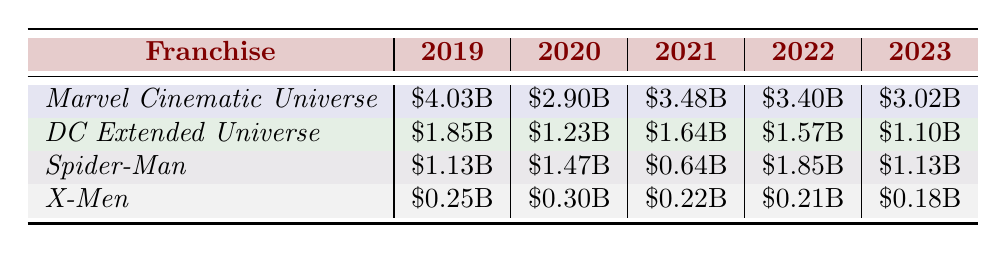What was the highest box office earning for the *Marvel Cinematic Universe* in the last five years? The highest box office earning for the *Marvel Cinematic Universe* occurred in 2019, which was \$4.03 billion.
Answer: \$4.03 billion Which superhero franchise had the lowest box office earnings in 2023? According to the table, the *X-Men* franchise had the lowest box office earnings in 2023, amounting to \$0.18 billion.
Answer: \$0.18 billion What is the total box office earnings of the *Spider-Man* franchise across all years listed? Summing the box office earnings for the *Spider-Man* franchise: \$1.13B + \$1.47B + \$0.64B + \$1.85B + \$1.13B gives \$5.22B.
Answer: \$5.22 billion Has the box office earning for the *DC Extended Universe* decreased every year from 2019 to 2023? Yes, the table shows that the earnings for the *DC Extended Universe* decreased from \$1.85 billion in 2019 to \$1.10 billion in 2023, indicating a continuous decrease.
Answer: Yes What was the average box office earning for the *X-Men* franchise over the last five years? The total box office earnings for *X-Men* is \$0.25B + \$0.30B + \$0.22B + \$0.21B + \$0.18B = \$1.16B. Dividing by 5 gives an average of \$0.232B.
Answer: \$0.232 billion Which franchise experienced the largest decrease in earnings from 2019 to 2020? Comparing the two years, the *Marvel Cinematic Universe* decreased from \$4.03B in 2019 to \$2.90B in 2020, which is a decrease of \$1.13 billion, the largest among all franchises.
Answer: *Marvel Cinematic Universe* Was there an increase in box office earnings for the *Spider-Man* franchise from 2021 to 2022? Yes, the *Spider-Man* franchise increased from \$0.64 billion in 2021 to \$1.85 billion in 2022, showing a significant increase.
Answer: Yes Calculate the total box office earnings for the *Marvel Cinematic Universe* from 2019 to 2023. Adding the earnings from each year: \$4.03B + \$2.90B + \$3.48B + \$3.40B + \$3.01B results in \$16.12B.
Answer: \$16.12 billion Which franchise had consistent earnings of over one billion dollars every year, except for one year? The *Spider-Man* franchise had earnings over one billion dollars in every year listed except for 2021, when it earned \$0.64 billion.
Answer: *Spider-Man* In which year did the *DC Extended Universe* earn more than \$1.5 billion? The *DC Extended Universe* earned more than \$1.5 billion only in 2019, totaling \$1.85 billion.
Answer: 2019 What was the difference in earnings between the *Marvel Cinematic Universe* and *DC Extended Universe* in 2022? The *Marvel Cinematic Universe* earned \$3.40 billion while the *DC Extended Universe* earned \$1.57 billion in 2022. The difference is \$3.40B - \$1.57B = \$1.83 billion.
Answer: \$1.83 billion 